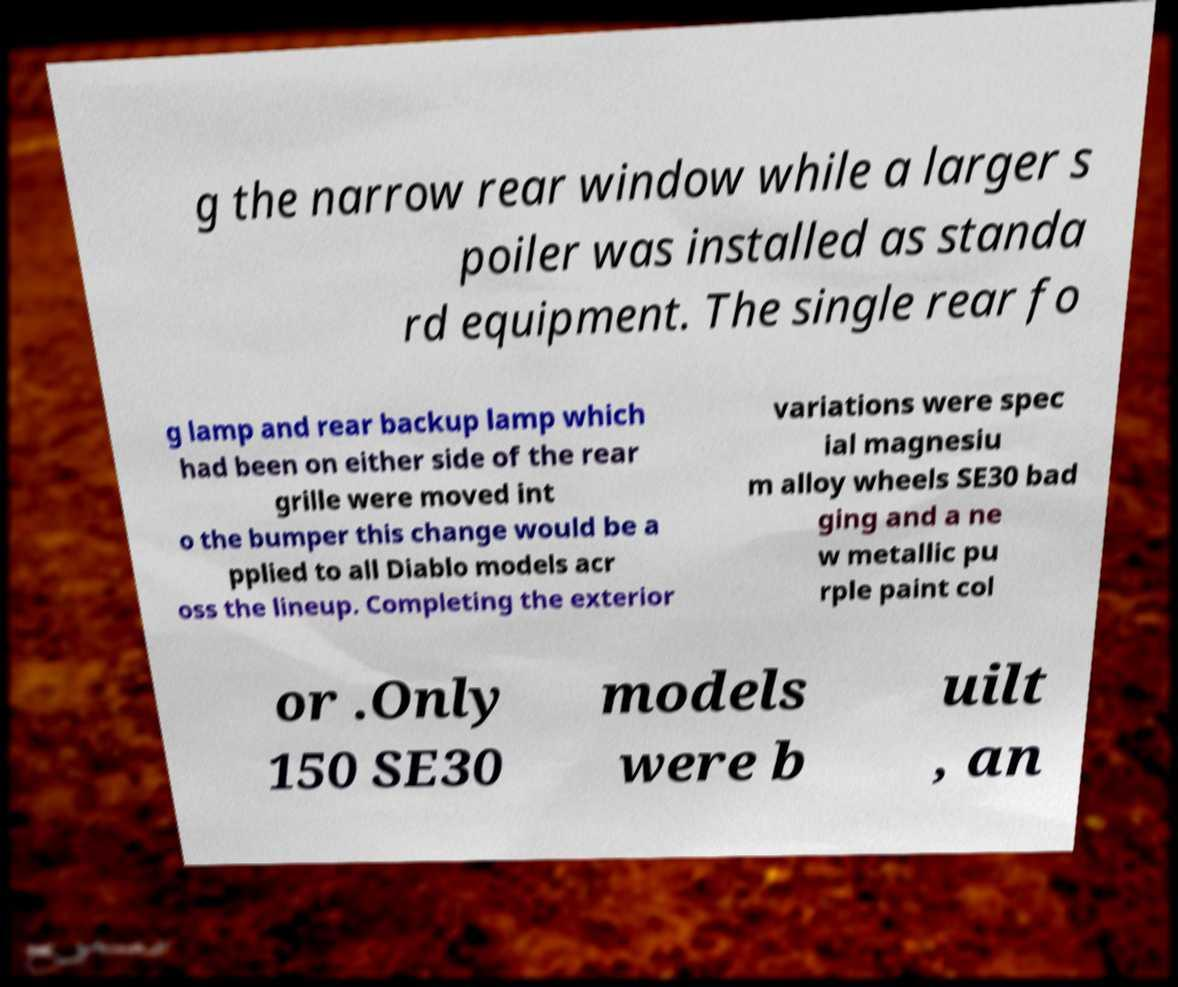Can you read and provide the text displayed in the image?This photo seems to have some interesting text. Can you extract and type it out for me? g the narrow rear window while a larger s poiler was installed as standa rd equipment. The single rear fo g lamp and rear backup lamp which had been on either side of the rear grille were moved int o the bumper this change would be a pplied to all Diablo models acr oss the lineup. Completing the exterior variations were spec ial magnesiu m alloy wheels SE30 bad ging and a ne w metallic pu rple paint col or .Only 150 SE30 models were b uilt , an 